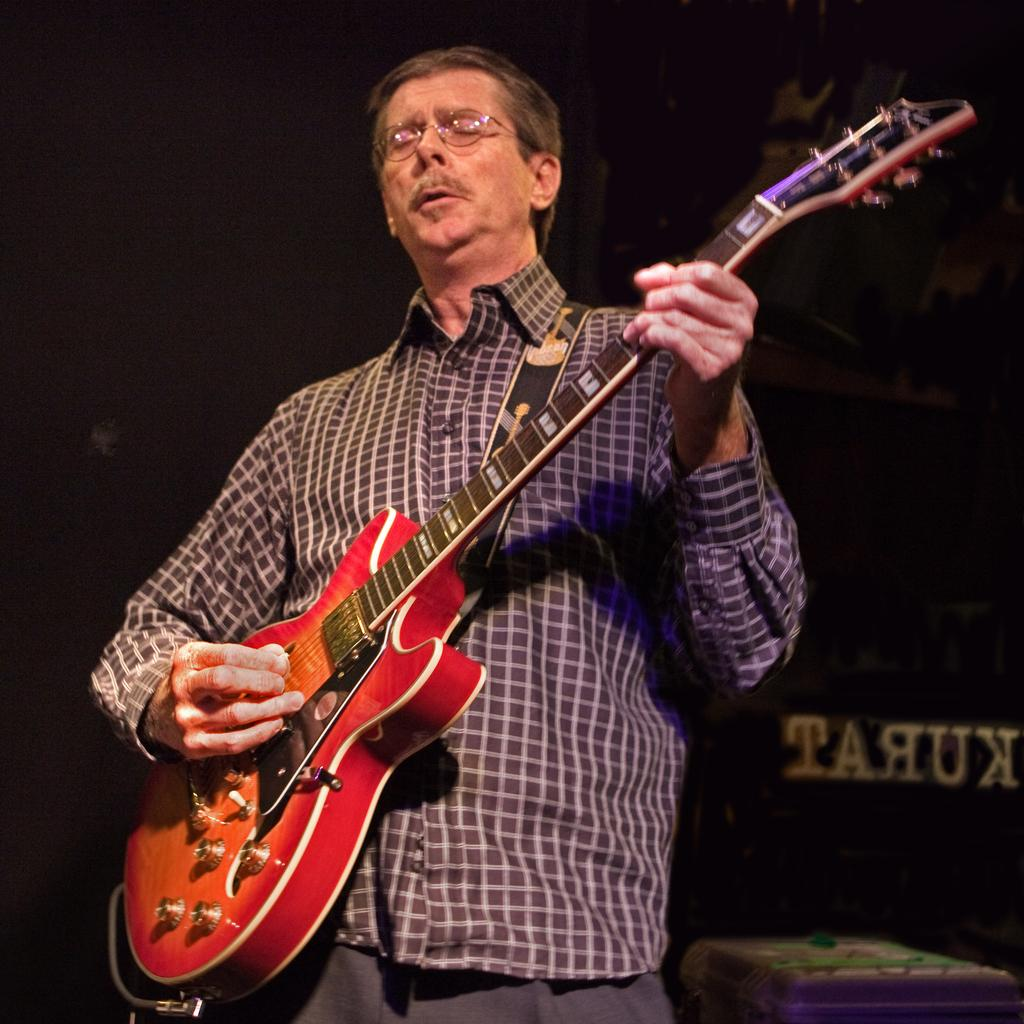What is the main subject of the image? There is a person in the image. What is the person doing in the image? The person is playing a guitar. Can you describe the background of the image? The background of the image is dark. Is there any text visible in the image? Yes, there is text in the bottom right of the image. What type of celery is the person holding while playing the guitar in the image? There is no celery present in the image; the person is playing a guitar. What type of hands does the kitty have in the image? There is no kitty present in the image. 